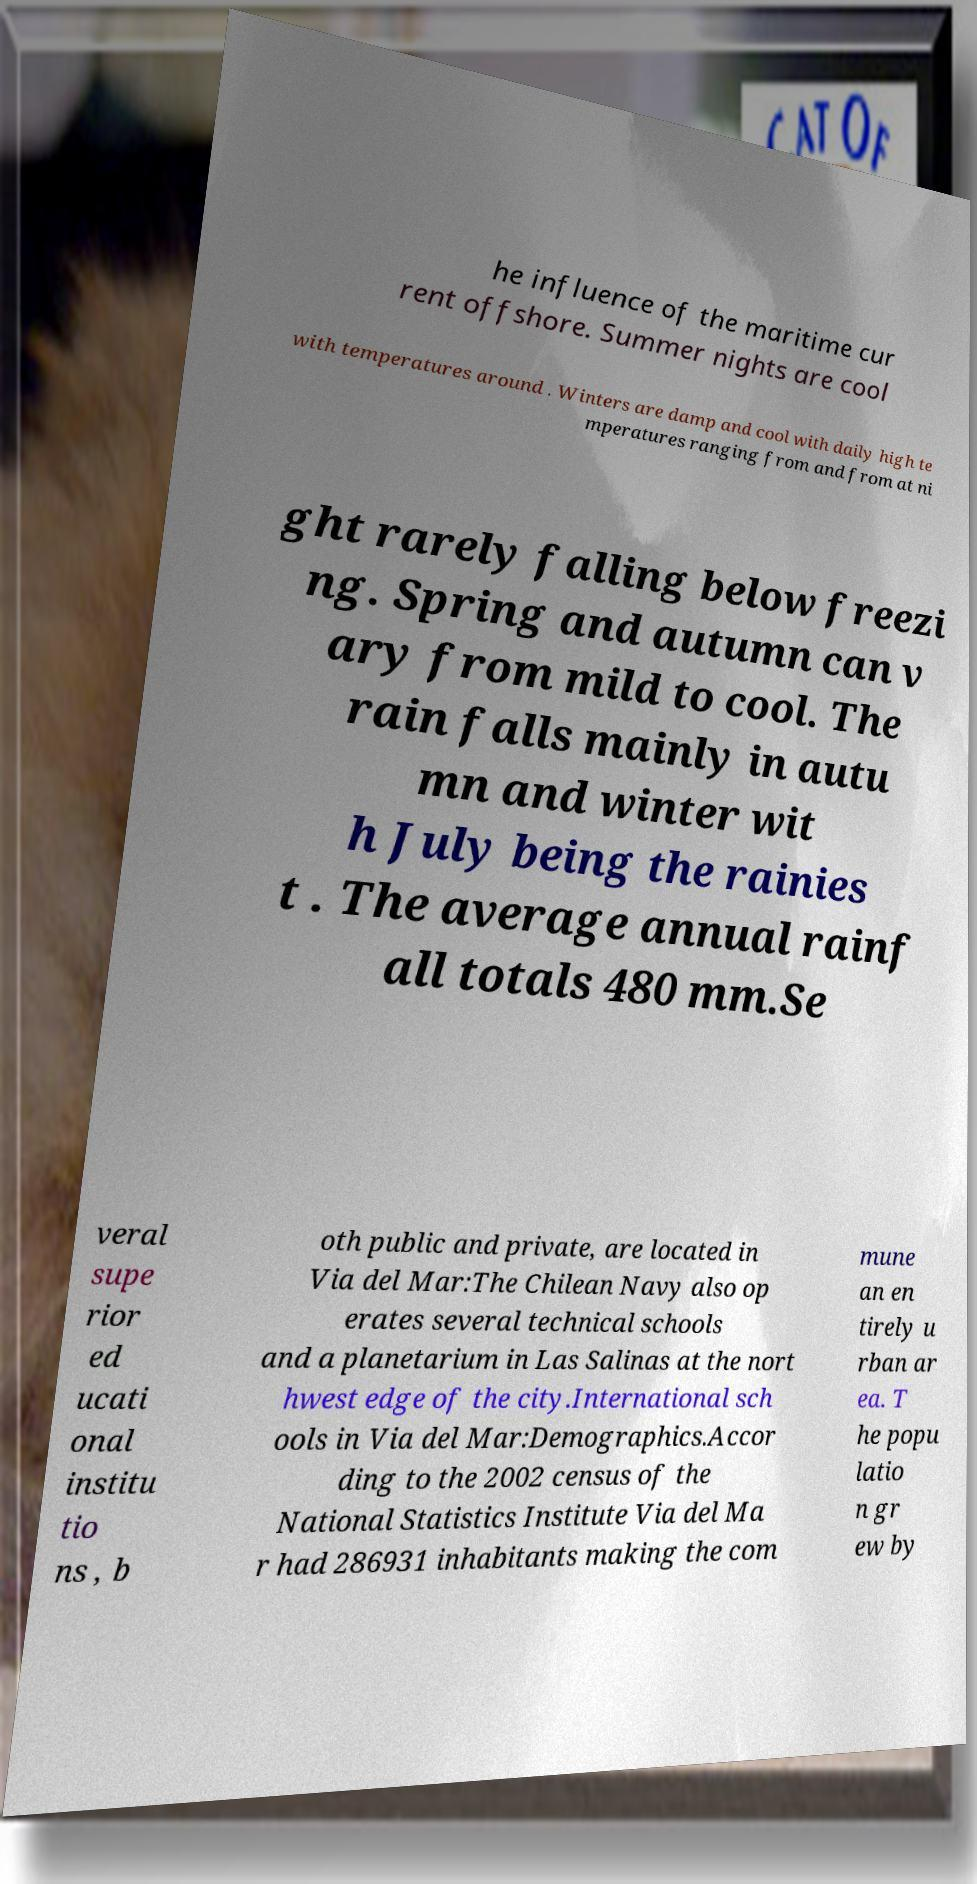For documentation purposes, I need the text within this image transcribed. Could you provide that? he influence of the maritime cur rent offshore. Summer nights are cool with temperatures around . Winters are damp and cool with daily high te mperatures ranging from and from at ni ght rarely falling below freezi ng. Spring and autumn can v ary from mild to cool. The rain falls mainly in autu mn and winter wit h July being the rainies t . The average annual rainf all totals 480 mm.Se veral supe rior ed ucati onal institu tio ns , b oth public and private, are located in Via del Mar:The Chilean Navy also op erates several technical schools and a planetarium in Las Salinas at the nort hwest edge of the city.International sch ools in Via del Mar:Demographics.Accor ding to the 2002 census of the National Statistics Institute Via del Ma r had 286931 inhabitants making the com mune an en tirely u rban ar ea. T he popu latio n gr ew by 